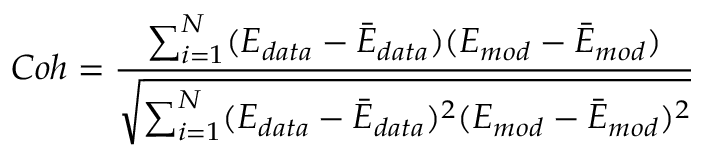<formula> <loc_0><loc_0><loc_500><loc_500>C o h = \frac { \sum _ { i = 1 } ^ { N } ( E _ { d a t a } - \bar { E } _ { d a t a } ) ( E _ { m o d } - \bar { E } _ { m o d } ) } { \sqrt { { \sum _ { i = 1 } ^ { N } } ( E _ { d a t a } - \bar { E } _ { d a t a } ) ^ { 2 } ( E _ { m o d } - \bar { E } _ { m o d } ) ^ { 2 } } }</formula> 